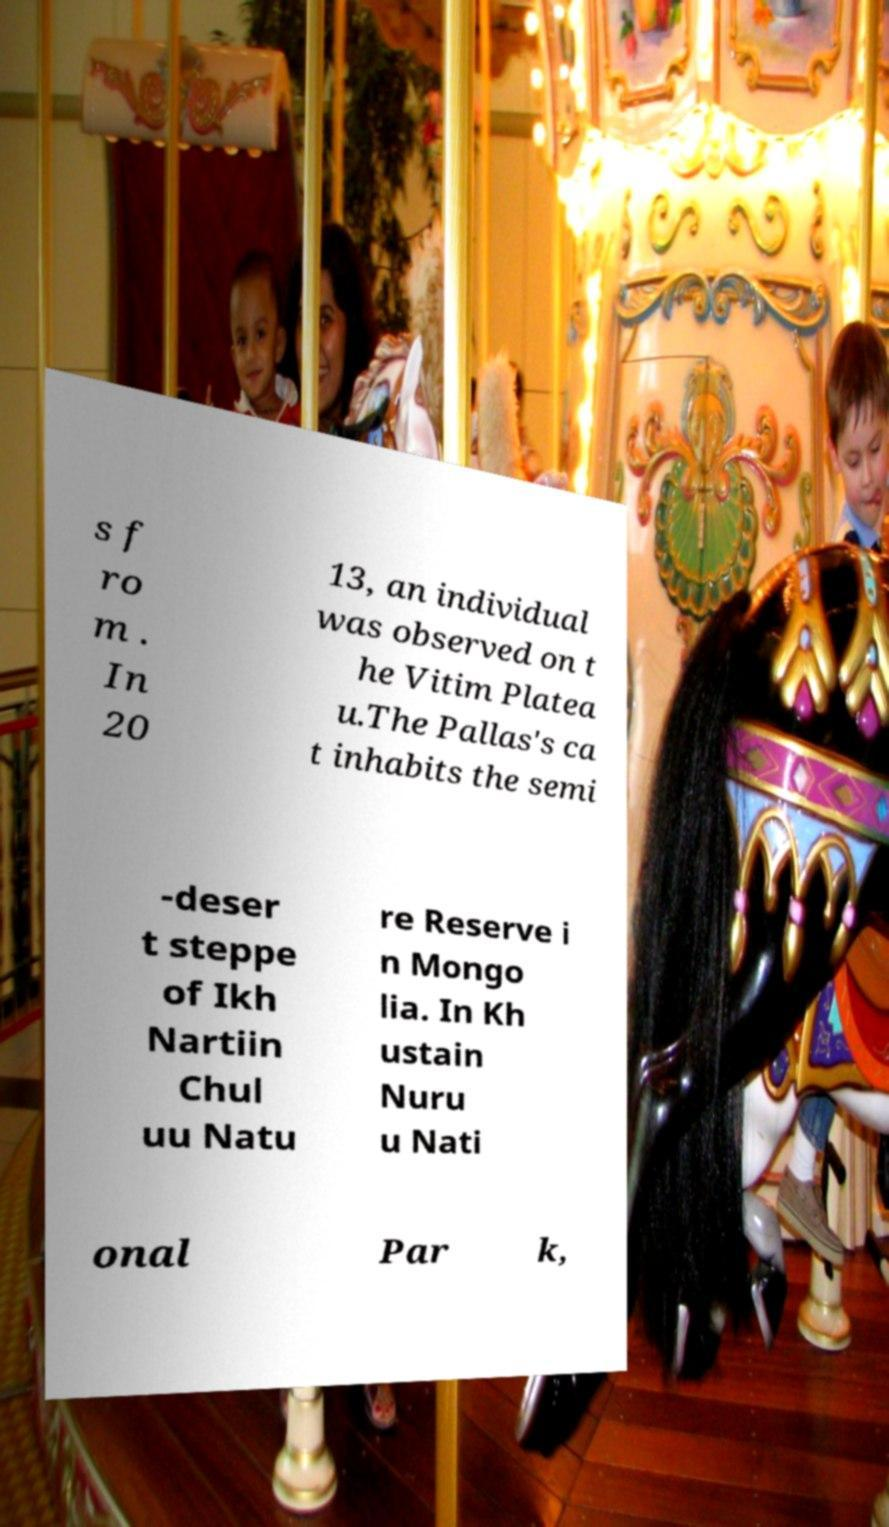Can you accurately transcribe the text from the provided image for me? s f ro m . In 20 13, an individual was observed on t he Vitim Platea u.The Pallas's ca t inhabits the semi -deser t steppe of Ikh Nartiin Chul uu Natu re Reserve i n Mongo lia. In Kh ustain Nuru u Nati onal Par k, 